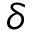Convert formula to latex. <formula><loc_0><loc_0><loc_500><loc_500>\delta</formula> 